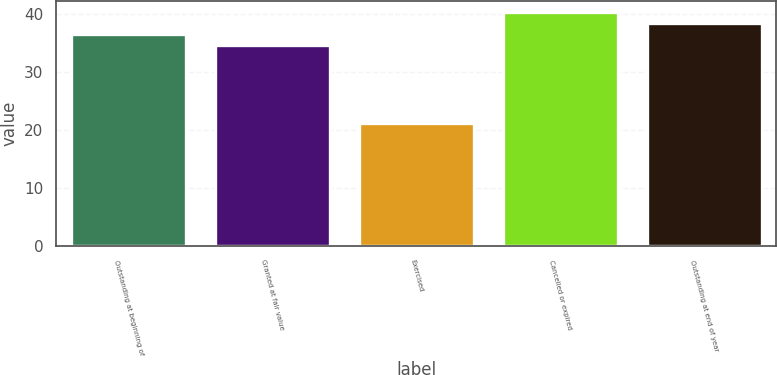Convert chart to OTSL. <chart><loc_0><loc_0><loc_500><loc_500><bar_chart><fcel>Outstanding at beginning of<fcel>Granted at fair value<fcel>Exercised<fcel>Cancelled or expired<fcel>Outstanding at end of year<nl><fcel>36.64<fcel>34.77<fcel>21.18<fcel>40.38<fcel>38.51<nl></chart> 